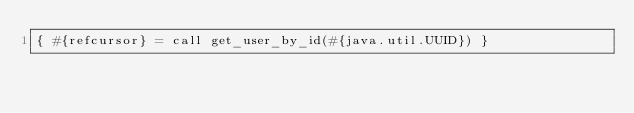<code> <loc_0><loc_0><loc_500><loc_500><_SQL_>{ #{refcursor} = call get_user_by_id(#{java.util.UUID}) }



</code> 